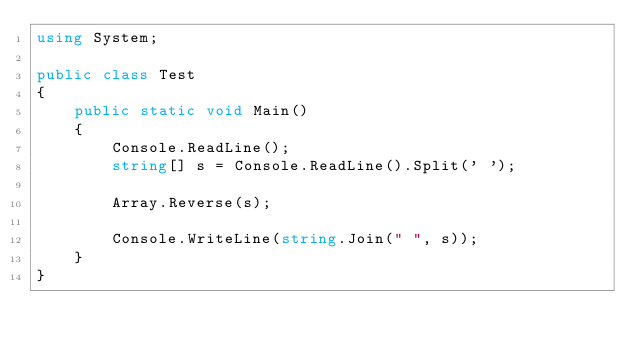Convert code to text. <code><loc_0><loc_0><loc_500><loc_500><_C#_>using System;

public class Test
{
	public static void Main()
	{
		Console.ReadLine();
		string[] s = Console.ReadLine().Split(' ');
		
		Array.Reverse(s);
		
		Console.WriteLine(string.Join(" ", s));
	}
}</code> 